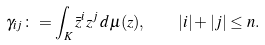Convert formula to latex. <formula><loc_0><loc_0><loc_500><loc_500>\gamma _ { i j } \colon = \int _ { K } \bar { z } ^ { i } z ^ { j } \, d \mu ( z ) , \quad \left | i \right | + \left | j \right | \leq n .</formula> 